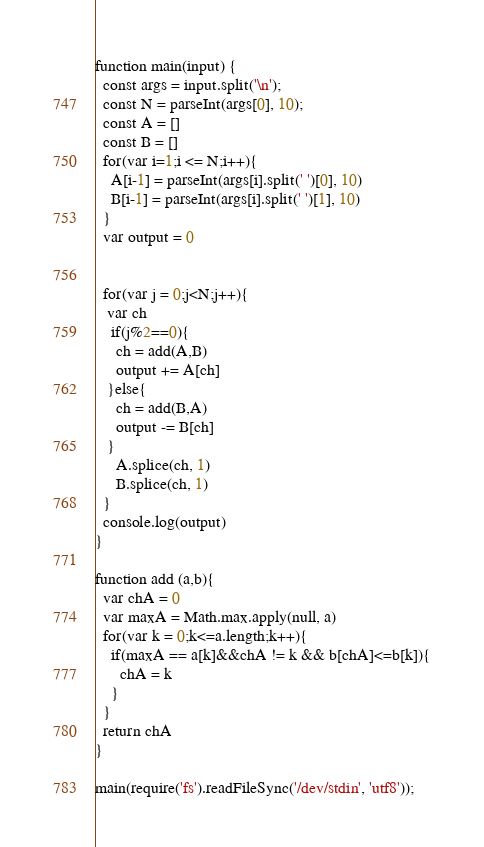Convert code to text. <code><loc_0><loc_0><loc_500><loc_500><_JavaScript_>function main(input) {
  const args = input.split('\n');
  const N = parseInt(args[0], 10);
  const A = []
  const B = []
  for(var i=1;i <= N;i++){
    A[i-1] = parseInt(args[i].split(' ')[0], 10)
    B[i-1] = parseInt(args[i].split(' ')[1], 10)
  }
  var output = 0
  
  
  for(var j = 0;j<N;j++){
   var ch
    if(j%2==0){
     ch = add(A,B)
     output += A[ch]
   }else{
     ch = add(B,A)
     output -= B[ch]
   }
     A.splice(ch, 1)
     B.splice(ch, 1)
  }
  console.log(output)
}

function add (a,b){
  var chA = 0
  var maxA = Math.max.apply(null, a)
  for(var k = 0;k<=a.length;k++){
    if(maxA == a[k]&&chA != k && b[chA]<=b[k]){
      chA = k
    }
  }
  return chA
}

main(require('fs').readFileSync('/dev/stdin', 'utf8'));</code> 